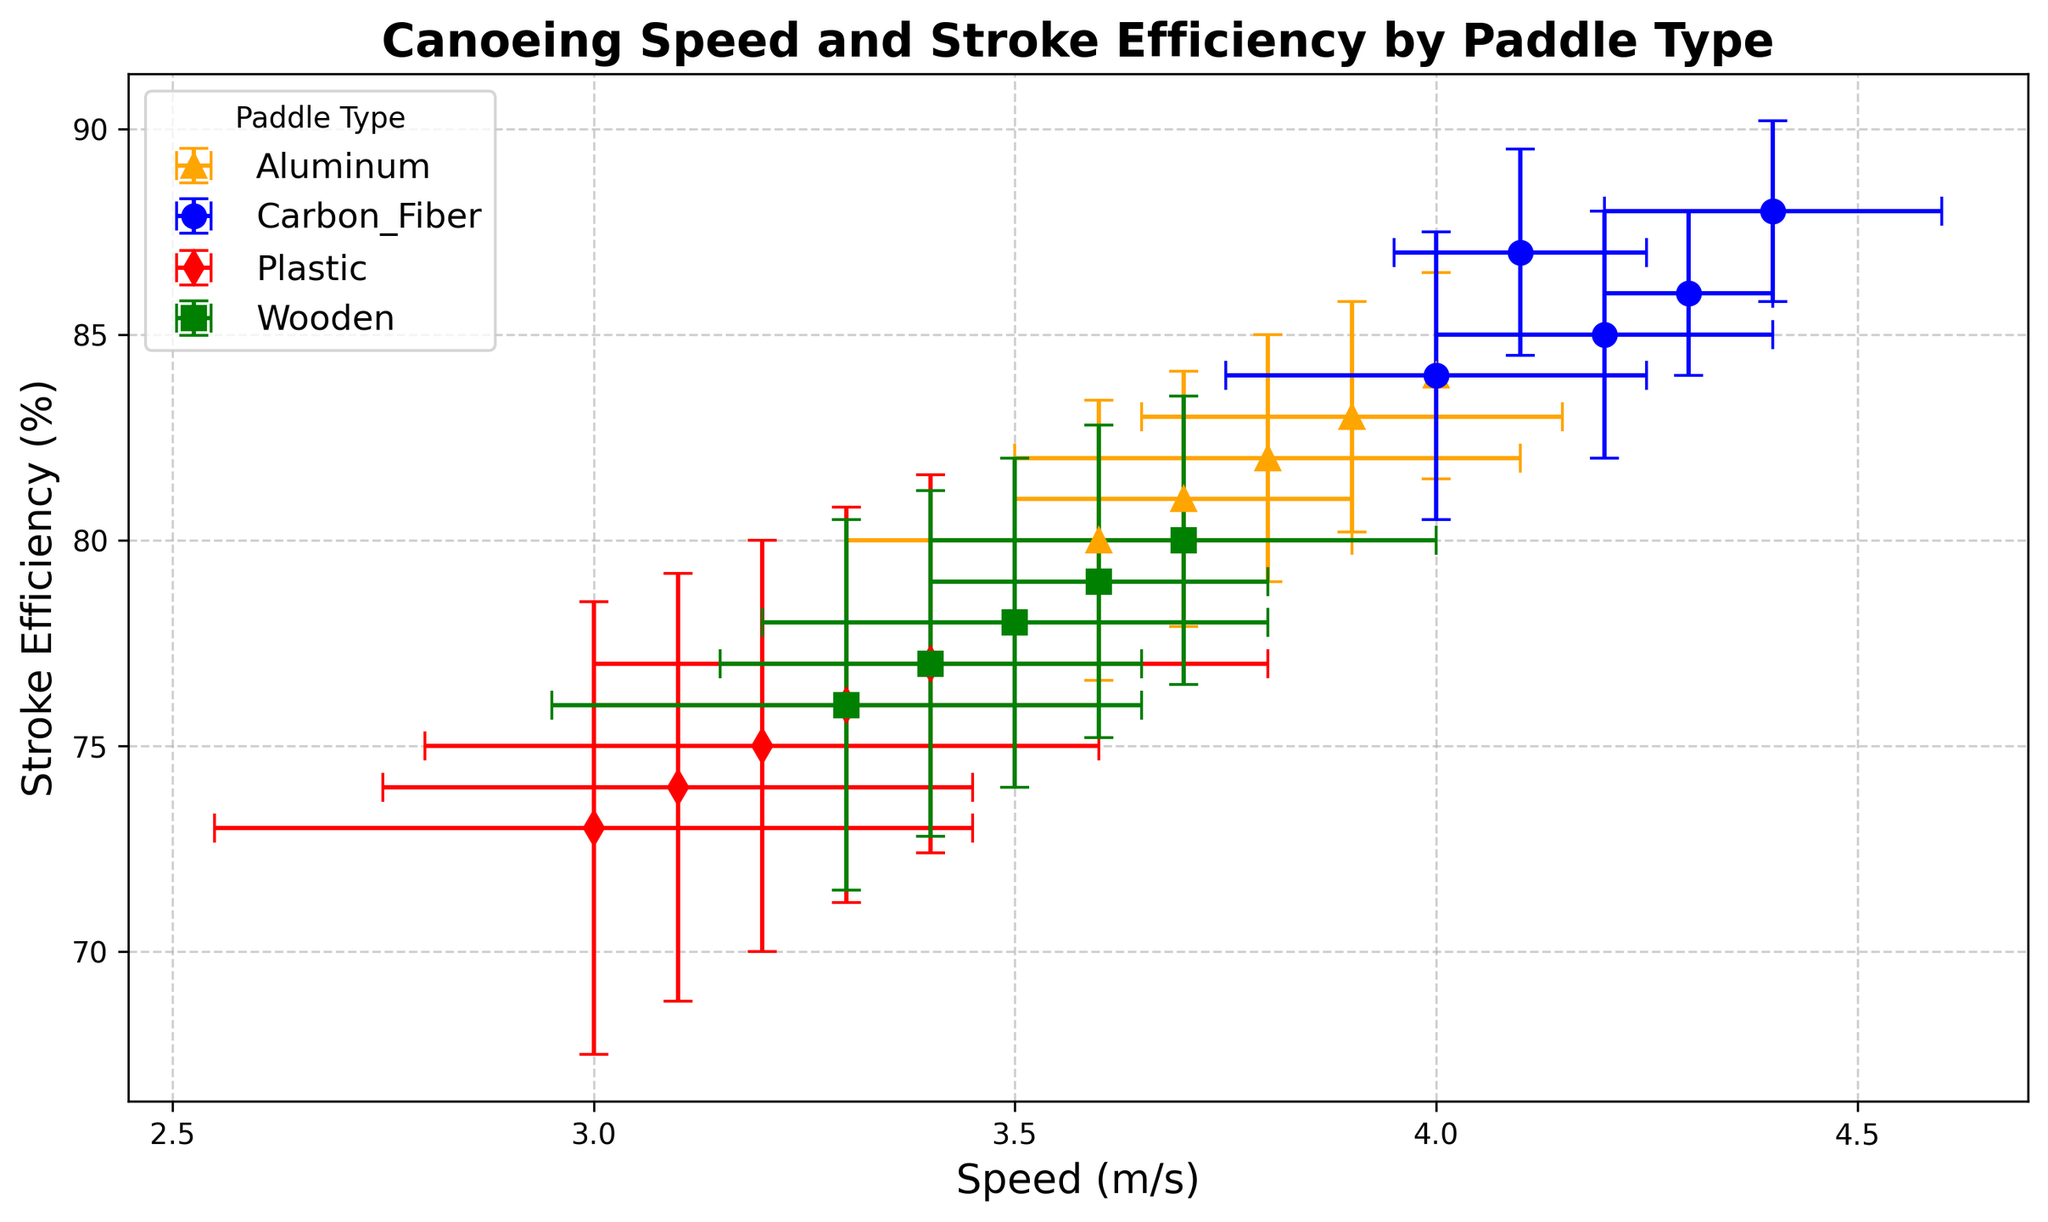What's the average speed of the Carbon Fiber paddle type? To find the average speed of the Carbon Fiber paddle type, sum all the speed values and divide by the number of data points. The speeds are 4.2, 4.1, 4.3, 4.0, 4.4. The sum is 21.0, and there are 5 data points, so the average speed is 21.0 / 5 = 4.2 m/s
Answer: 4.2 m/s Which paddle type has the highest stroke efficiency? From the chart, we identify that the data points of each paddle type are color-coded. The highest stroke efficiency value is associated with the blue markers, which represent the Carbon Fiber paddle type, with a value of 88%.
Answer: Carbon Fiber What is the range of speed for the Wooden paddle type? The range is found by subtracting the smallest speed value from the largest speed value among the Wooden paddle type. The speeds are 3.5, 3.4, 3.6, 3.3, 3.7. The range is 3.7 - 3.3 = 0.4 m/s
Answer: 0.4 m/s How does the stroke efficiency variability of Aluminum compare to Plastic? We compare the error bars' extent on the y-axis (stroke efficiency) for both paddle types. Aluminum (orange markers) has stroke efficiency error values around 3%, while Plastic (red markers) has error values around 5%, indicating higher variability for Plastic.
Answer: Plastic shows higher variability Which paddle type has the smallest average stroke efficiency, and what is that value? By visually comparing each group, the Plastic paddle type (red markers) shows the smallest stroke efficiency values. The average is calculated by summing the stroke efficiency values (75, 74, 76, 73, 77) and dividing by the number of data points. The sum is 375, and there are 5 data points, so the average stroke efficiency is 375 / 5 = 75%
Answer: Plastic, 75% Is there any overlap in speed values between Carbon Fiber and Aluminum paddle types? By comparing the speed values of Carbon Fiber (4.2, 4.1, 4.3, 4.0, 4.4) and Aluminum (3.8, 3.9, 3.7, 3.6, 4.0), it can be seen that the value 4.0 m/s is present in both groups, indicating an overlap in speed.
Answer: Yes What is the average stroke efficiency for the Aluminum paddle type? Sum the stroke efficiency values for Aluminum (82, 83, 81, 80, 84) and divide by the number of data points. The sum is 410, and there are 5 data points, so the average stroke efficiency is 410 / 5 = 82%
Answer: 82% Comparing the Carbon Fiber and Wooden paddle types, which one has lower overall speed variability, and how do you know? By examining the x-error bars representing speed variability, Carbon Fiber (blue markers) has smaller error bars than Wooden (green markers), indicating lower overall speed variability for the Carbon Fiber paddle type.
Answer: Carbon Fiber 